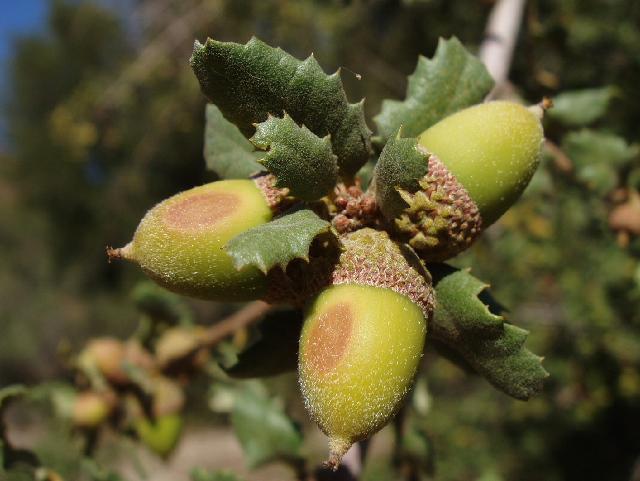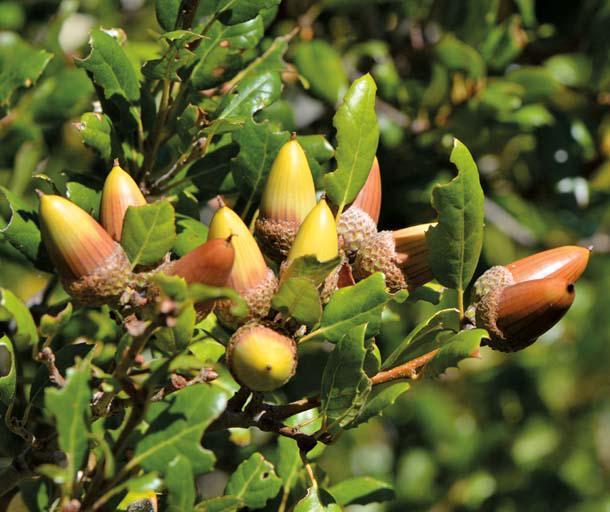The first image is the image on the left, the second image is the image on the right. Evaluate the accuracy of this statement regarding the images: "The left image shows two green acorns in the foreground which lack any brown patches on their skins, and the right image shows foliage without individually distinguishable acorns.". Is it true? Answer yes or no. No. The first image is the image on the left, the second image is the image on the right. Given the left and right images, does the statement "One of the images is an acorn close up and the other only shows branches and leaves." hold true? Answer yes or no. No. 